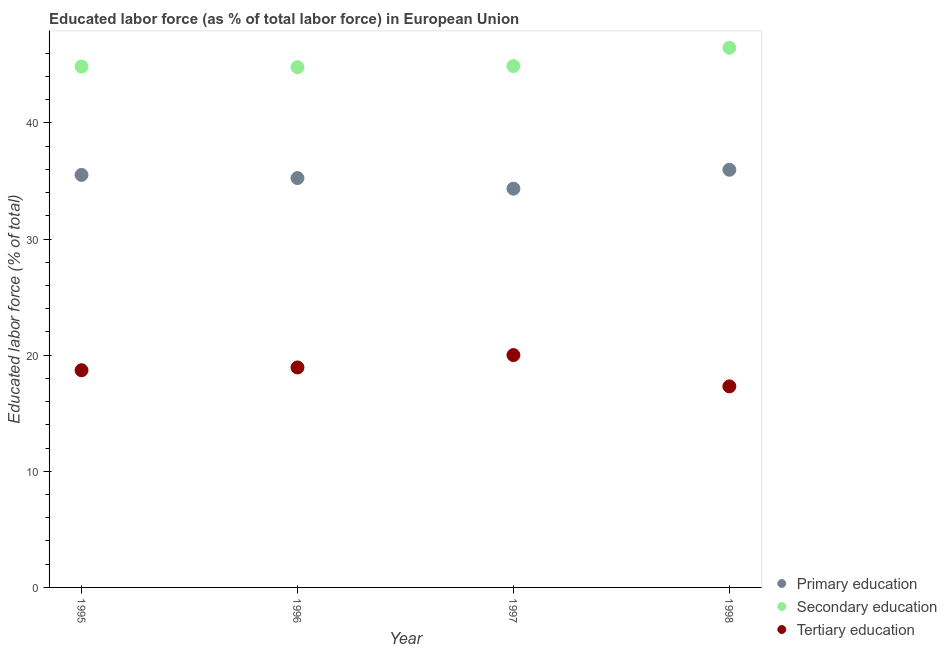How many different coloured dotlines are there?
Offer a terse response. 3. What is the percentage of labor force who received secondary education in 1998?
Your response must be concise. 46.47. Across all years, what is the maximum percentage of labor force who received primary education?
Ensure brevity in your answer.  35.97. Across all years, what is the minimum percentage of labor force who received primary education?
Your answer should be compact. 34.34. In which year was the percentage of labor force who received secondary education maximum?
Give a very brief answer. 1998. In which year was the percentage of labor force who received secondary education minimum?
Provide a succinct answer. 1996. What is the total percentage of labor force who received secondary education in the graph?
Provide a short and direct response. 181.03. What is the difference between the percentage of labor force who received tertiary education in 1996 and that in 1997?
Keep it short and to the point. -1.07. What is the difference between the percentage of labor force who received tertiary education in 1997 and the percentage of labor force who received primary education in 1998?
Make the answer very short. -15.96. What is the average percentage of labor force who received tertiary education per year?
Your answer should be compact. 18.74. In the year 1996, what is the difference between the percentage of labor force who received tertiary education and percentage of labor force who received primary education?
Provide a short and direct response. -16.31. In how many years, is the percentage of labor force who received primary education greater than 14 %?
Your answer should be very brief. 4. What is the ratio of the percentage of labor force who received tertiary education in 1996 to that in 1997?
Ensure brevity in your answer.  0.95. Is the difference between the percentage of labor force who received tertiary education in 1995 and 1996 greater than the difference between the percentage of labor force who received primary education in 1995 and 1996?
Keep it short and to the point. No. What is the difference between the highest and the second highest percentage of labor force who received primary education?
Keep it short and to the point. 0.44. What is the difference between the highest and the lowest percentage of labor force who received tertiary education?
Your response must be concise. 2.69. Is the sum of the percentage of labor force who received primary education in 1995 and 1996 greater than the maximum percentage of labor force who received tertiary education across all years?
Provide a short and direct response. Yes. Is it the case that in every year, the sum of the percentage of labor force who received primary education and percentage of labor force who received secondary education is greater than the percentage of labor force who received tertiary education?
Keep it short and to the point. Yes. Does the percentage of labor force who received primary education monotonically increase over the years?
Your response must be concise. No. Is the percentage of labor force who received primary education strictly less than the percentage of labor force who received tertiary education over the years?
Offer a very short reply. No. What is the difference between two consecutive major ticks on the Y-axis?
Your answer should be very brief. 10. Does the graph contain any zero values?
Provide a succinct answer. No. Does the graph contain grids?
Offer a very short reply. No. Where does the legend appear in the graph?
Offer a very short reply. Bottom right. How are the legend labels stacked?
Make the answer very short. Vertical. What is the title of the graph?
Make the answer very short. Educated labor force (as % of total labor force) in European Union. What is the label or title of the Y-axis?
Your answer should be compact. Educated labor force (% of total). What is the Educated labor force (% of total) of Primary education in 1995?
Keep it short and to the point. 35.52. What is the Educated labor force (% of total) of Secondary education in 1995?
Give a very brief answer. 44.85. What is the Educated labor force (% of total) in Tertiary education in 1995?
Offer a terse response. 18.7. What is the Educated labor force (% of total) in Primary education in 1996?
Offer a very short reply. 35.25. What is the Educated labor force (% of total) in Secondary education in 1996?
Ensure brevity in your answer.  44.8. What is the Educated labor force (% of total) of Tertiary education in 1996?
Your response must be concise. 18.94. What is the Educated labor force (% of total) of Primary education in 1997?
Your response must be concise. 34.34. What is the Educated labor force (% of total) in Secondary education in 1997?
Your response must be concise. 44.9. What is the Educated labor force (% of total) of Tertiary education in 1997?
Your answer should be compact. 20.01. What is the Educated labor force (% of total) of Primary education in 1998?
Your answer should be compact. 35.97. What is the Educated labor force (% of total) in Secondary education in 1998?
Ensure brevity in your answer.  46.47. What is the Educated labor force (% of total) of Tertiary education in 1998?
Offer a very short reply. 17.31. Across all years, what is the maximum Educated labor force (% of total) in Primary education?
Give a very brief answer. 35.97. Across all years, what is the maximum Educated labor force (% of total) in Secondary education?
Offer a very short reply. 46.47. Across all years, what is the maximum Educated labor force (% of total) of Tertiary education?
Your answer should be compact. 20.01. Across all years, what is the minimum Educated labor force (% of total) of Primary education?
Provide a succinct answer. 34.34. Across all years, what is the minimum Educated labor force (% of total) in Secondary education?
Keep it short and to the point. 44.8. Across all years, what is the minimum Educated labor force (% of total) of Tertiary education?
Your response must be concise. 17.31. What is the total Educated labor force (% of total) of Primary education in the graph?
Offer a terse response. 141.08. What is the total Educated labor force (% of total) of Secondary education in the graph?
Make the answer very short. 181.03. What is the total Educated labor force (% of total) of Tertiary education in the graph?
Keep it short and to the point. 74.97. What is the difference between the Educated labor force (% of total) of Primary education in 1995 and that in 1996?
Give a very brief answer. 0.27. What is the difference between the Educated labor force (% of total) in Secondary education in 1995 and that in 1996?
Your answer should be compact. 0.05. What is the difference between the Educated labor force (% of total) in Tertiary education in 1995 and that in 1996?
Your response must be concise. -0.24. What is the difference between the Educated labor force (% of total) in Primary education in 1995 and that in 1997?
Your response must be concise. 1.18. What is the difference between the Educated labor force (% of total) of Secondary education in 1995 and that in 1997?
Your answer should be very brief. -0.04. What is the difference between the Educated labor force (% of total) in Tertiary education in 1995 and that in 1997?
Your answer should be compact. -1.3. What is the difference between the Educated labor force (% of total) in Primary education in 1995 and that in 1998?
Your answer should be very brief. -0.44. What is the difference between the Educated labor force (% of total) of Secondary education in 1995 and that in 1998?
Your answer should be very brief. -1.62. What is the difference between the Educated labor force (% of total) of Tertiary education in 1995 and that in 1998?
Provide a succinct answer. 1.39. What is the difference between the Educated labor force (% of total) of Primary education in 1996 and that in 1997?
Ensure brevity in your answer.  0.91. What is the difference between the Educated labor force (% of total) in Secondary education in 1996 and that in 1997?
Give a very brief answer. -0.1. What is the difference between the Educated labor force (% of total) of Tertiary education in 1996 and that in 1997?
Keep it short and to the point. -1.07. What is the difference between the Educated labor force (% of total) of Primary education in 1996 and that in 1998?
Provide a short and direct response. -0.72. What is the difference between the Educated labor force (% of total) of Secondary education in 1996 and that in 1998?
Offer a terse response. -1.67. What is the difference between the Educated labor force (% of total) in Tertiary education in 1996 and that in 1998?
Make the answer very short. 1.63. What is the difference between the Educated labor force (% of total) of Primary education in 1997 and that in 1998?
Ensure brevity in your answer.  -1.63. What is the difference between the Educated labor force (% of total) of Secondary education in 1997 and that in 1998?
Your answer should be very brief. -1.58. What is the difference between the Educated labor force (% of total) in Tertiary education in 1997 and that in 1998?
Provide a short and direct response. 2.69. What is the difference between the Educated labor force (% of total) of Primary education in 1995 and the Educated labor force (% of total) of Secondary education in 1996?
Provide a short and direct response. -9.28. What is the difference between the Educated labor force (% of total) in Primary education in 1995 and the Educated labor force (% of total) in Tertiary education in 1996?
Your answer should be compact. 16.58. What is the difference between the Educated labor force (% of total) in Secondary education in 1995 and the Educated labor force (% of total) in Tertiary education in 1996?
Provide a short and direct response. 25.91. What is the difference between the Educated labor force (% of total) of Primary education in 1995 and the Educated labor force (% of total) of Secondary education in 1997?
Make the answer very short. -9.37. What is the difference between the Educated labor force (% of total) of Primary education in 1995 and the Educated labor force (% of total) of Tertiary education in 1997?
Ensure brevity in your answer.  15.51. What is the difference between the Educated labor force (% of total) of Secondary education in 1995 and the Educated labor force (% of total) of Tertiary education in 1997?
Ensure brevity in your answer.  24.84. What is the difference between the Educated labor force (% of total) in Primary education in 1995 and the Educated labor force (% of total) in Secondary education in 1998?
Your response must be concise. -10.95. What is the difference between the Educated labor force (% of total) of Primary education in 1995 and the Educated labor force (% of total) of Tertiary education in 1998?
Offer a very short reply. 18.21. What is the difference between the Educated labor force (% of total) of Secondary education in 1995 and the Educated labor force (% of total) of Tertiary education in 1998?
Offer a terse response. 27.54. What is the difference between the Educated labor force (% of total) of Primary education in 1996 and the Educated labor force (% of total) of Secondary education in 1997?
Your response must be concise. -9.65. What is the difference between the Educated labor force (% of total) of Primary education in 1996 and the Educated labor force (% of total) of Tertiary education in 1997?
Keep it short and to the point. 15.24. What is the difference between the Educated labor force (% of total) of Secondary education in 1996 and the Educated labor force (% of total) of Tertiary education in 1997?
Make the answer very short. 24.79. What is the difference between the Educated labor force (% of total) of Primary education in 1996 and the Educated labor force (% of total) of Secondary education in 1998?
Keep it short and to the point. -11.22. What is the difference between the Educated labor force (% of total) of Primary education in 1996 and the Educated labor force (% of total) of Tertiary education in 1998?
Ensure brevity in your answer.  17.94. What is the difference between the Educated labor force (% of total) of Secondary education in 1996 and the Educated labor force (% of total) of Tertiary education in 1998?
Make the answer very short. 27.49. What is the difference between the Educated labor force (% of total) in Primary education in 1997 and the Educated labor force (% of total) in Secondary education in 1998?
Ensure brevity in your answer.  -12.13. What is the difference between the Educated labor force (% of total) in Primary education in 1997 and the Educated labor force (% of total) in Tertiary education in 1998?
Provide a short and direct response. 17.03. What is the difference between the Educated labor force (% of total) of Secondary education in 1997 and the Educated labor force (% of total) of Tertiary education in 1998?
Provide a short and direct response. 27.58. What is the average Educated labor force (% of total) of Primary education per year?
Your response must be concise. 35.27. What is the average Educated labor force (% of total) of Secondary education per year?
Provide a short and direct response. 45.26. What is the average Educated labor force (% of total) of Tertiary education per year?
Make the answer very short. 18.74. In the year 1995, what is the difference between the Educated labor force (% of total) in Primary education and Educated labor force (% of total) in Secondary education?
Provide a short and direct response. -9.33. In the year 1995, what is the difference between the Educated labor force (% of total) of Primary education and Educated labor force (% of total) of Tertiary education?
Ensure brevity in your answer.  16.82. In the year 1995, what is the difference between the Educated labor force (% of total) of Secondary education and Educated labor force (% of total) of Tertiary education?
Your response must be concise. 26.15. In the year 1996, what is the difference between the Educated labor force (% of total) of Primary education and Educated labor force (% of total) of Secondary education?
Keep it short and to the point. -9.55. In the year 1996, what is the difference between the Educated labor force (% of total) in Primary education and Educated labor force (% of total) in Tertiary education?
Give a very brief answer. 16.31. In the year 1996, what is the difference between the Educated labor force (% of total) of Secondary education and Educated labor force (% of total) of Tertiary education?
Ensure brevity in your answer.  25.86. In the year 1997, what is the difference between the Educated labor force (% of total) of Primary education and Educated labor force (% of total) of Secondary education?
Offer a terse response. -10.56. In the year 1997, what is the difference between the Educated labor force (% of total) of Primary education and Educated labor force (% of total) of Tertiary education?
Your answer should be very brief. 14.33. In the year 1997, what is the difference between the Educated labor force (% of total) of Secondary education and Educated labor force (% of total) of Tertiary education?
Keep it short and to the point. 24.89. In the year 1998, what is the difference between the Educated labor force (% of total) of Primary education and Educated labor force (% of total) of Secondary education?
Your answer should be very brief. -10.51. In the year 1998, what is the difference between the Educated labor force (% of total) of Primary education and Educated labor force (% of total) of Tertiary education?
Give a very brief answer. 18.65. In the year 1998, what is the difference between the Educated labor force (% of total) in Secondary education and Educated labor force (% of total) in Tertiary education?
Your answer should be compact. 29.16. What is the ratio of the Educated labor force (% of total) of Primary education in 1995 to that in 1996?
Your answer should be very brief. 1.01. What is the ratio of the Educated labor force (% of total) in Tertiary education in 1995 to that in 1996?
Your answer should be compact. 0.99. What is the ratio of the Educated labor force (% of total) in Primary education in 1995 to that in 1997?
Ensure brevity in your answer.  1.03. What is the ratio of the Educated labor force (% of total) of Secondary education in 1995 to that in 1997?
Offer a terse response. 1. What is the ratio of the Educated labor force (% of total) of Tertiary education in 1995 to that in 1997?
Offer a terse response. 0.93. What is the ratio of the Educated labor force (% of total) in Secondary education in 1995 to that in 1998?
Give a very brief answer. 0.97. What is the ratio of the Educated labor force (% of total) of Tertiary education in 1995 to that in 1998?
Your answer should be very brief. 1.08. What is the ratio of the Educated labor force (% of total) of Primary education in 1996 to that in 1997?
Your answer should be very brief. 1.03. What is the ratio of the Educated labor force (% of total) in Secondary education in 1996 to that in 1997?
Provide a short and direct response. 1. What is the ratio of the Educated labor force (% of total) of Tertiary education in 1996 to that in 1997?
Your response must be concise. 0.95. What is the ratio of the Educated labor force (% of total) of Primary education in 1996 to that in 1998?
Ensure brevity in your answer.  0.98. What is the ratio of the Educated labor force (% of total) in Secondary education in 1996 to that in 1998?
Your response must be concise. 0.96. What is the ratio of the Educated labor force (% of total) of Tertiary education in 1996 to that in 1998?
Provide a short and direct response. 1.09. What is the ratio of the Educated labor force (% of total) of Primary education in 1997 to that in 1998?
Make the answer very short. 0.95. What is the ratio of the Educated labor force (% of total) of Secondary education in 1997 to that in 1998?
Your answer should be compact. 0.97. What is the ratio of the Educated labor force (% of total) in Tertiary education in 1997 to that in 1998?
Your answer should be compact. 1.16. What is the difference between the highest and the second highest Educated labor force (% of total) of Primary education?
Ensure brevity in your answer.  0.44. What is the difference between the highest and the second highest Educated labor force (% of total) in Secondary education?
Provide a short and direct response. 1.58. What is the difference between the highest and the second highest Educated labor force (% of total) of Tertiary education?
Provide a short and direct response. 1.07. What is the difference between the highest and the lowest Educated labor force (% of total) in Primary education?
Provide a short and direct response. 1.63. What is the difference between the highest and the lowest Educated labor force (% of total) in Secondary education?
Offer a terse response. 1.67. What is the difference between the highest and the lowest Educated labor force (% of total) in Tertiary education?
Ensure brevity in your answer.  2.69. 